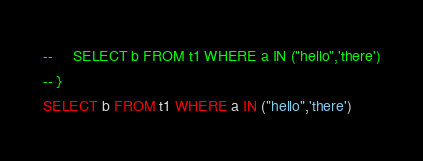<code> <loc_0><loc_0><loc_500><loc_500><_SQL_>--     SELECT b FROM t1 WHERE a IN ("hello",'there')
-- }
SELECT b FROM t1 WHERE a IN ("hello",'there')</code> 